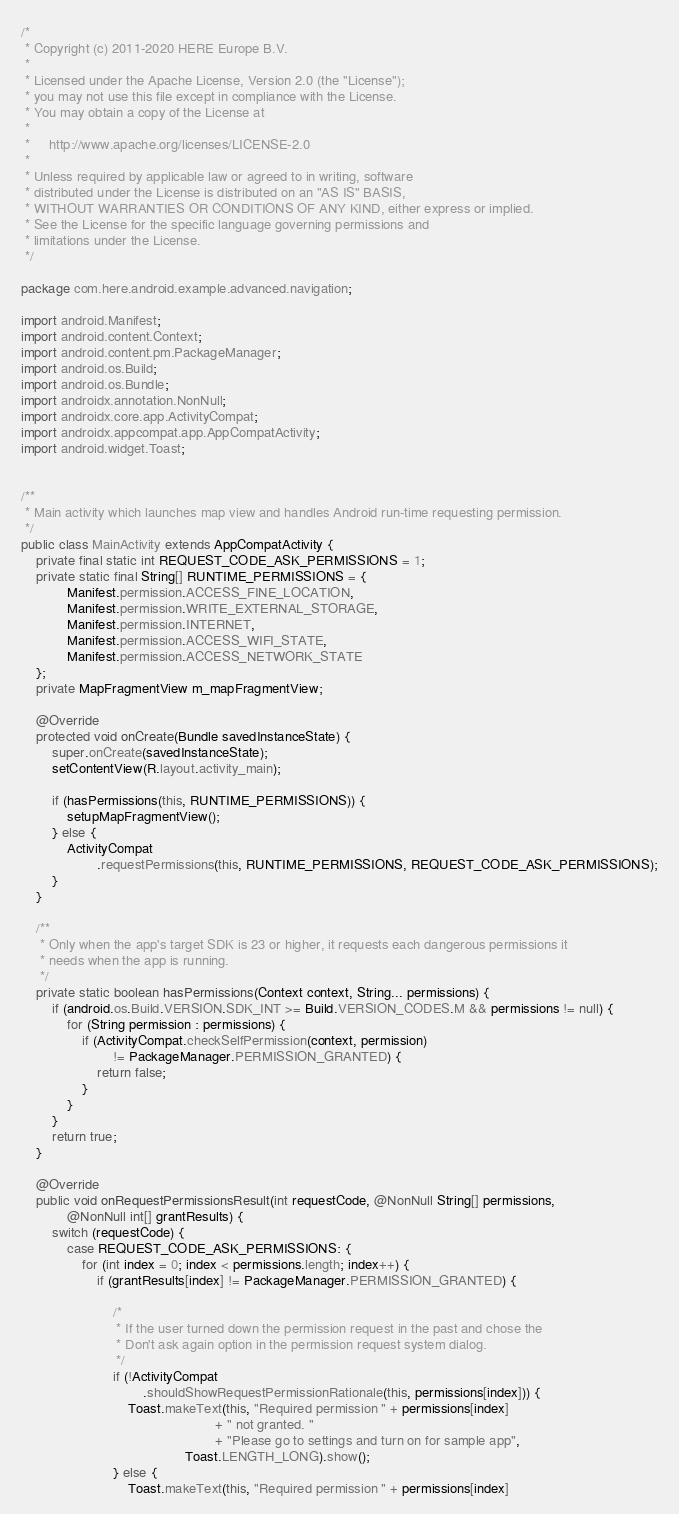<code> <loc_0><loc_0><loc_500><loc_500><_Java_>/*
 * Copyright (c) 2011-2020 HERE Europe B.V.
 *
 * Licensed under the Apache License, Version 2.0 (the "License");
 * you may not use this file except in compliance with the License.
 * You may obtain a copy of the License at
 *
 *     http://www.apache.org/licenses/LICENSE-2.0
 *
 * Unless required by applicable law or agreed to in writing, software
 * distributed under the License is distributed on an "AS IS" BASIS,
 * WITHOUT WARRANTIES OR CONDITIONS OF ANY KIND, either express or implied.
 * See the License for the specific language governing permissions and
 * limitations under the License.
 */

package com.here.android.example.advanced.navigation;

import android.Manifest;
import android.content.Context;
import android.content.pm.PackageManager;
import android.os.Build;
import android.os.Bundle;
import androidx.annotation.NonNull;
import androidx.core.app.ActivityCompat;
import androidx.appcompat.app.AppCompatActivity;
import android.widget.Toast;


/**
 * Main activity which launches map view and handles Android run-time requesting permission.
 */
public class MainActivity extends AppCompatActivity {
    private final static int REQUEST_CODE_ASK_PERMISSIONS = 1;
    private static final String[] RUNTIME_PERMISSIONS = {
            Manifest.permission.ACCESS_FINE_LOCATION,
            Manifest.permission.WRITE_EXTERNAL_STORAGE,
            Manifest.permission.INTERNET,
            Manifest.permission.ACCESS_WIFI_STATE,
            Manifest.permission.ACCESS_NETWORK_STATE
    };
    private MapFragmentView m_mapFragmentView;

    @Override
    protected void onCreate(Bundle savedInstanceState) {
        super.onCreate(savedInstanceState);
        setContentView(R.layout.activity_main);

        if (hasPermissions(this, RUNTIME_PERMISSIONS)) {
            setupMapFragmentView();
        } else {
            ActivityCompat
                    .requestPermissions(this, RUNTIME_PERMISSIONS, REQUEST_CODE_ASK_PERMISSIONS);
        }
    }

    /**
     * Only when the app's target SDK is 23 or higher, it requests each dangerous permissions it
     * needs when the app is running.
     */
    private static boolean hasPermissions(Context context, String... permissions) {
        if (android.os.Build.VERSION.SDK_INT >= Build.VERSION_CODES.M && permissions != null) {
            for (String permission : permissions) {
                if (ActivityCompat.checkSelfPermission(context, permission)
                        != PackageManager.PERMISSION_GRANTED) {
                    return false;
                }
            }
        }
        return true;
    }

    @Override
    public void onRequestPermissionsResult(int requestCode, @NonNull String[] permissions,
            @NonNull int[] grantResults) {
        switch (requestCode) {
            case REQUEST_CODE_ASK_PERMISSIONS: {
                for (int index = 0; index < permissions.length; index++) {
                    if (grantResults[index] != PackageManager.PERMISSION_GRANTED) {

                        /*
                         * If the user turned down the permission request in the past and chose the
                         * Don't ask again option in the permission request system dialog.
                         */
                        if (!ActivityCompat
                                .shouldShowRequestPermissionRationale(this, permissions[index])) {
                            Toast.makeText(this, "Required permission " + permissions[index]
                                                   + " not granted. "
                                                   + "Please go to settings and turn on for sample app",
                                           Toast.LENGTH_LONG).show();
                        } else {
                            Toast.makeText(this, "Required permission " + permissions[index]</code> 